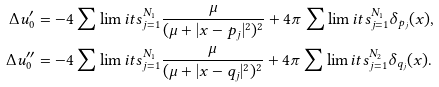<formula> <loc_0><loc_0><loc_500><loc_500>\Delta u _ { 0 } ^ { \prime } & = - 4 \sum \lim i t s _ { j = 1 } ^ { N _ { 1 } } { \frac { \mu } { ( \mu + | x - p _ { j } | ^ { 2 } ) ^ { 2 } } } + 4 \pi \sum \lim i t s _ { j = 1 } ^ { N _ { 1 } } { \delta _ { p _ { j } } ( x ) } , \\ \Delta u _ { 0 } ^ { \prime \prime } & = - 4 \sum \lim i t s _ { j = 1 } ^ { N _ { 1 } } { \frac { \mu } { ( \mu + | x - q _ { j } | ^ { 2 } ) ^ { 2 } } } + 4 \pi \sum \lim i t s _ { j = 1 } ^ { N _ { 2 } } { \delta _ { q _ { j } } ( x ) } .</formula> 